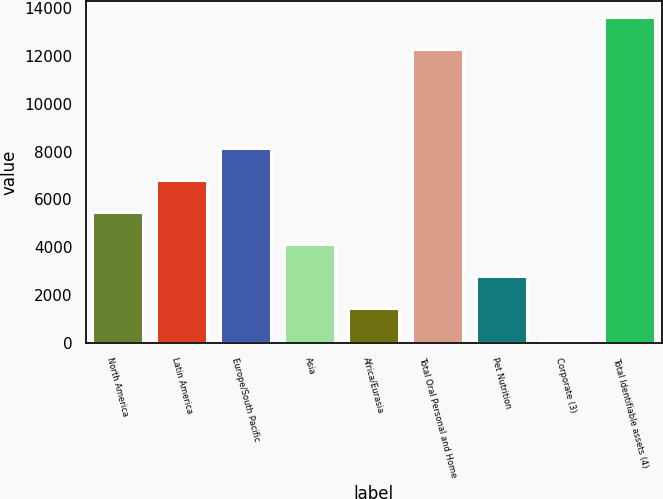Convert chart. <chart><loc_0><loc_0><loc_500><loc_500><bar_chart><fcel>North America<fcel>Latin America<fcel>Europe/South Pacific<fcel>Asia<fcel>Africa/Eurasia<fcel>Total Oral Personal and Home<fcel>Pet Nutrition<fcel>Corporate (3)<fcel>Total Identifiable assets (4)<nl><fcel>5467.6<fcel>6799.5<fcel>8131.4<fcel>4135.7<fcel>1471.9<fcel>12268<fcel>2803.8<fcel>140<fcel>13599.9<nl></chart> 